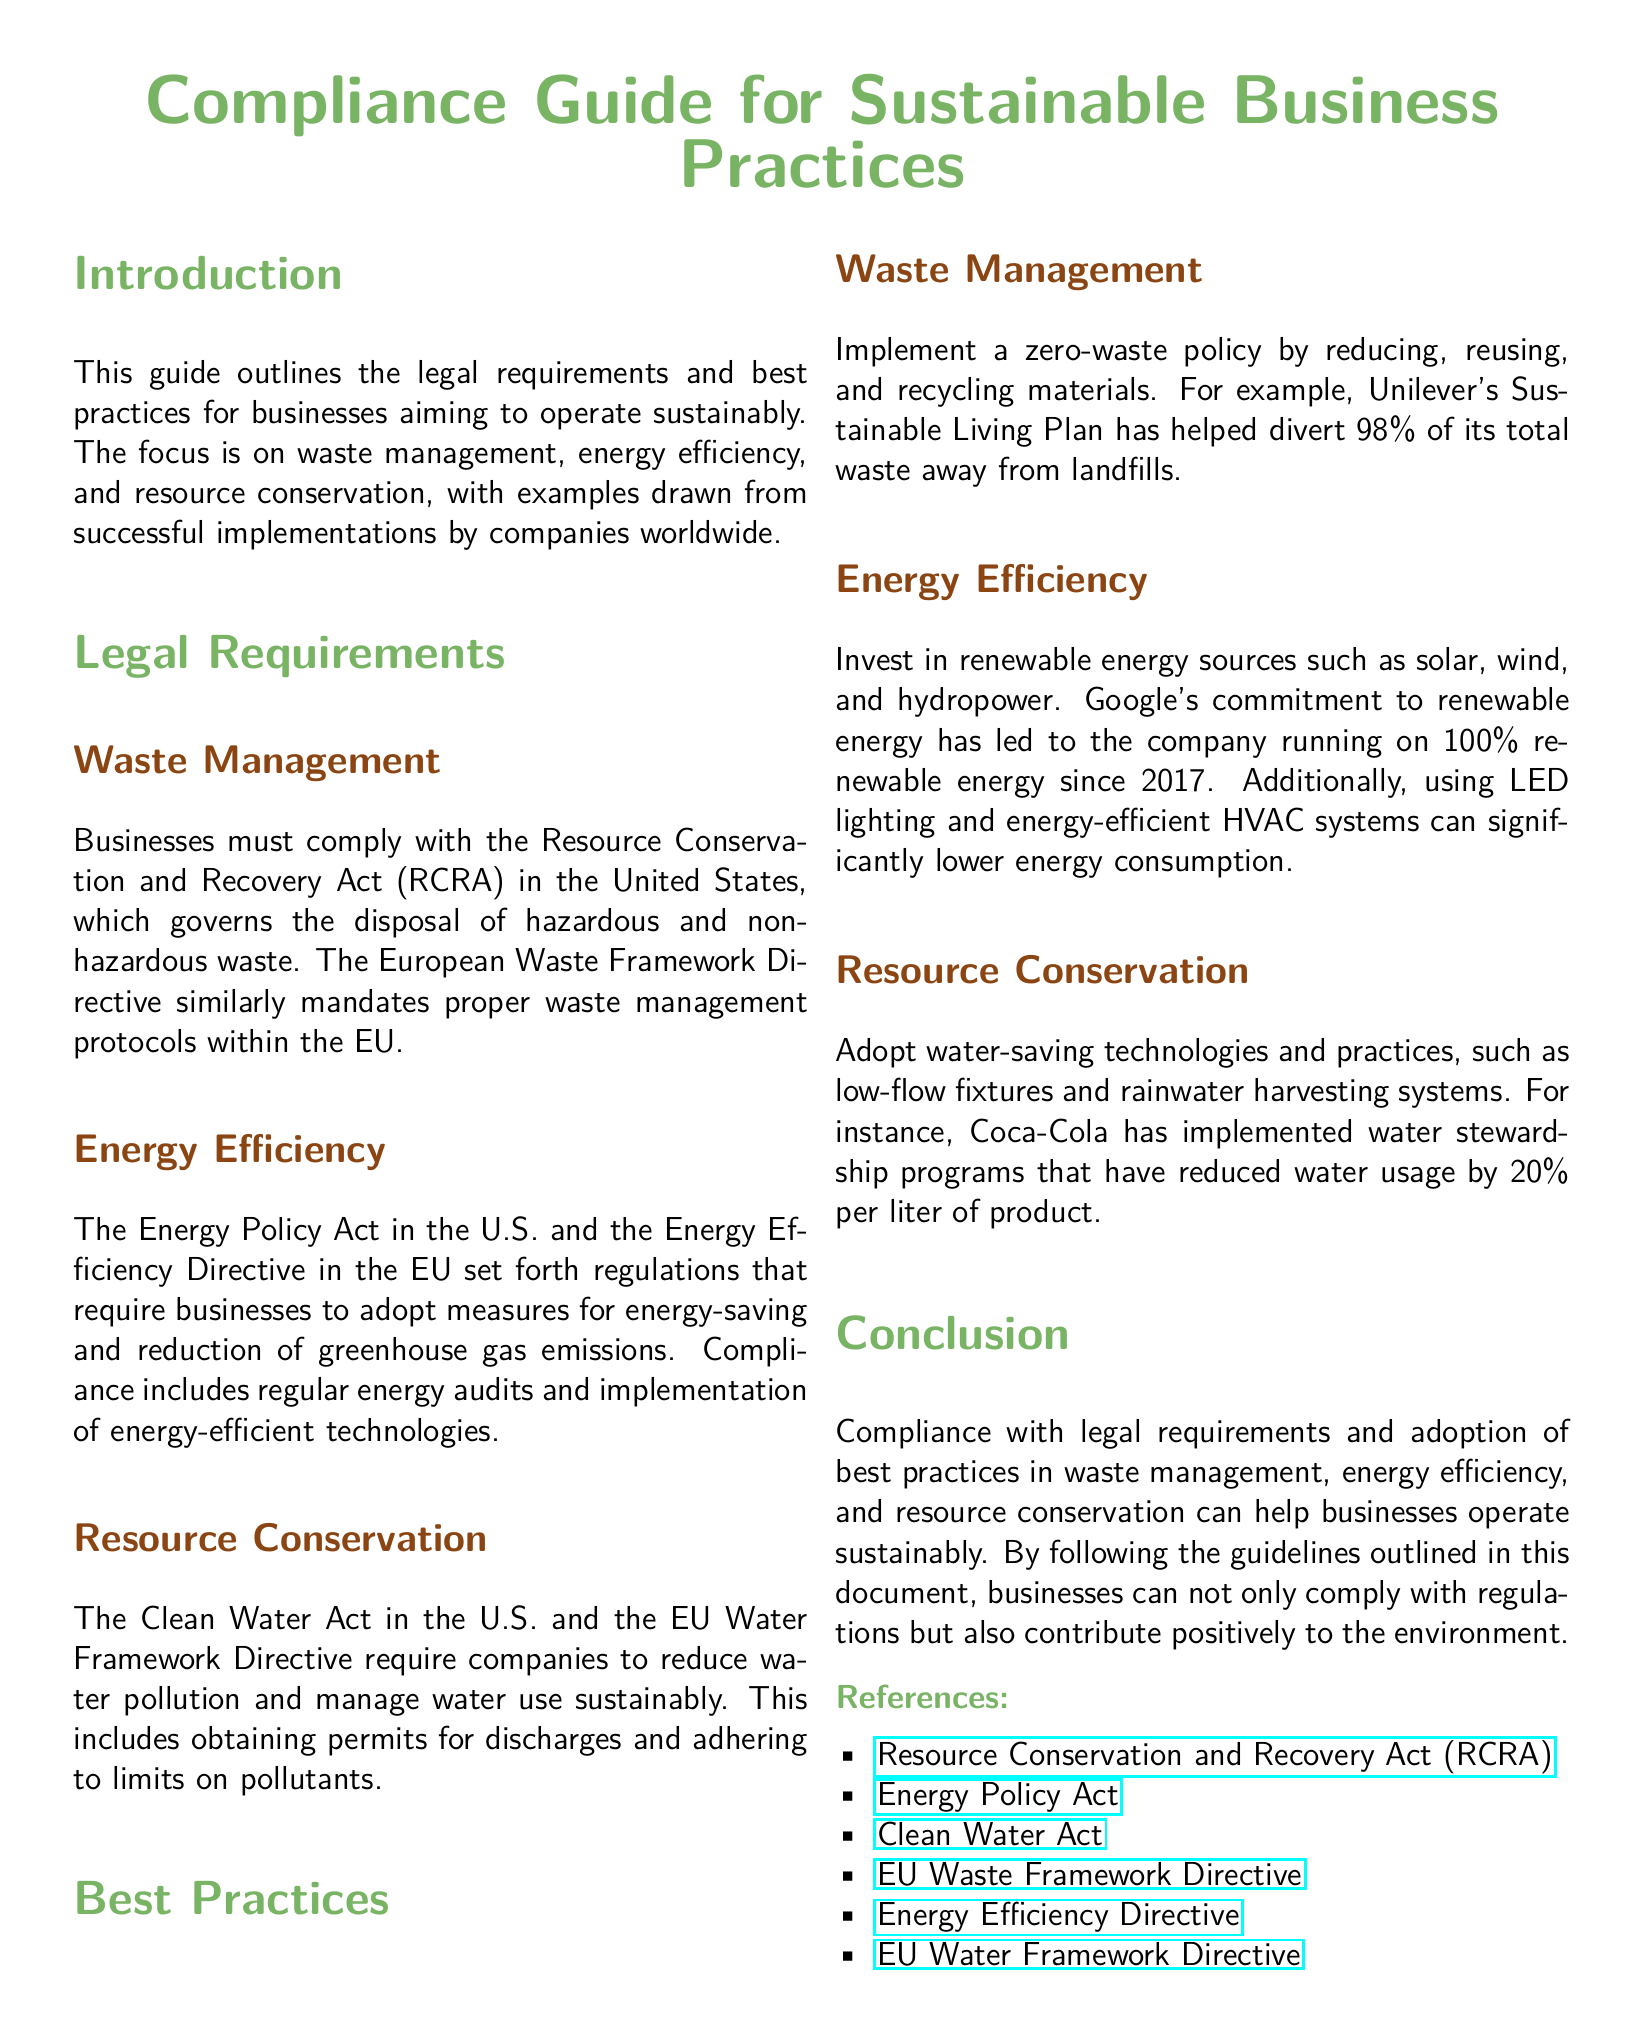What act governs hazardous waste disposal in the U.S.? The Resource Conservation and Recovery Act (RCRA) governs the disposal of hazardous waste in the U.S.
Answer: Resource Conservation and Recovery Act (RCRA) What is required for energy-saving measures in the U.S.? The Energy Policy Act in the U.S. requires businesses to adopt measures for energy-saving.
Answer: Energy Policy Act What company reduced its waste away from landfills by 98%? Unilever's Sustainable Living Plan has helped divert 98% of its total waste away from landfills.
Answer: Unilever What energy source has Google committed to using since 2017? Google has committed to running on 100% renewable energy since 2017.
Answer: 100% renewable energy What percentage of water usage did Coca-Cola reduce per liter of product? Coca-Cola has implemented programs that have reduced water usage by 20% per liter of product.
Answer: 20% What directive requires companies to manage water use sustainably in the EU? The EU Water Framework Directive requires companies to manage water use sustainably.
Answer: EU Water Framework Directive What is a best practice for waste management mentioned in the document? Implementing a zero-waste policy is a best practice for waste management.
Answer: Zero-waste policy What type of technologies should businesses invest in for energy efficiency? Businesses should invest in renewable energy sources.
Answer: Renewable energy sources What legal document outlines sustainability best practices? The Compliance Guide for Sustainable Business Practices outlines the best practices.
Answer: Compliance Guide for Sustainable Business Practices 